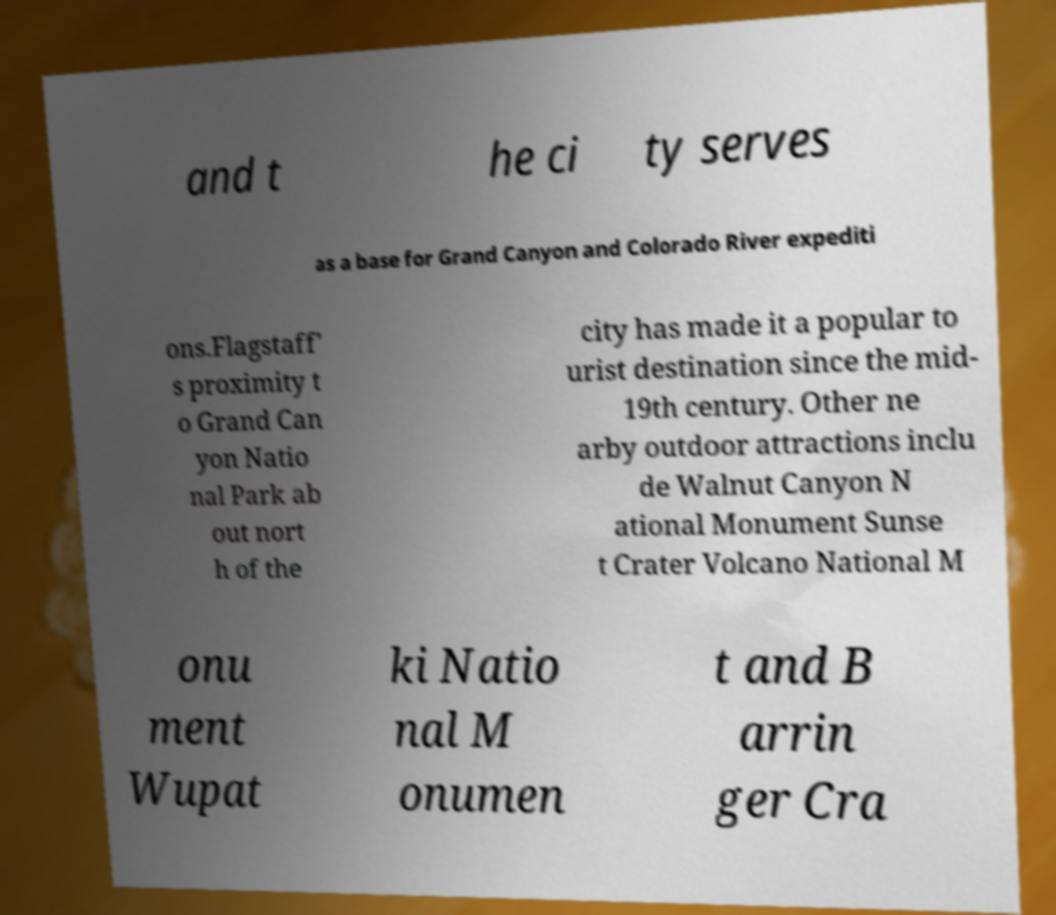Can you accurately transcribe the text from the provided image for me? and t he ci ty serves as a base for Grand Canyon and Colorado River expediti ons.Flagstaff' s proximity t o Grand Can yon Natio nal Park ab out nort h of the city has made it a popular to urist destination since the mid- 19th century. Other ne arby outdoor attractions inclu de Walnut Canyon N ational Monument Sunse t Crater Volcano National M onu ment Wupat ki Natio nal M onumen t and B arrin ger Cra 